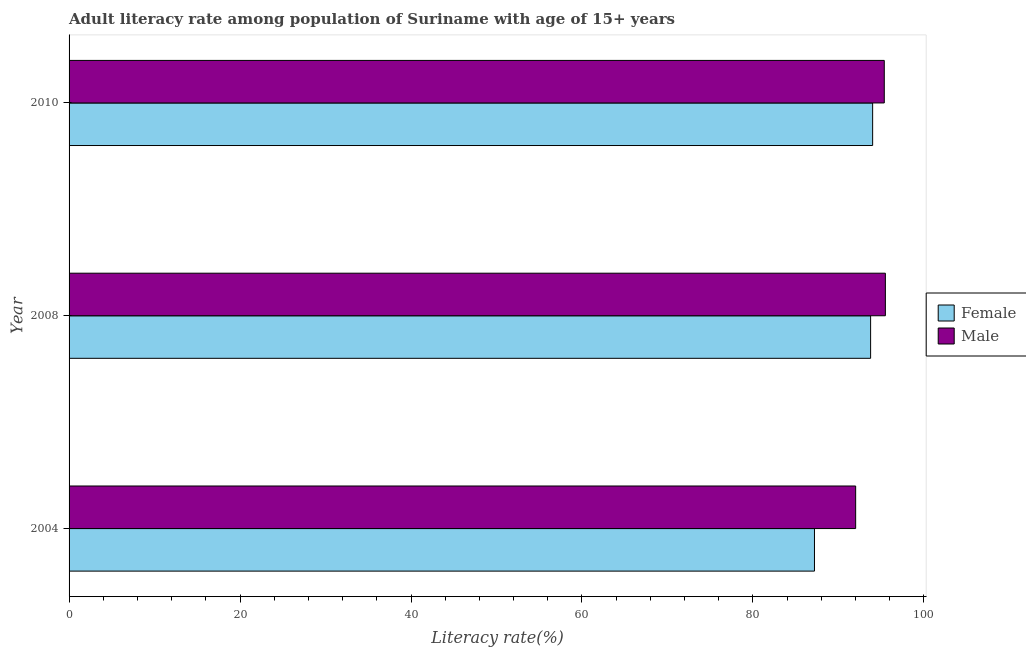Are the number of bars on each tick of the Y-axis equal?
Your answer should be very brief. Yes. How many bars are there on the 1st tick from the top?
Offer a terse response. 2. How many bars are there on the 1st tick from the bottom?
Provide a succinct answer. 2. In how many cases, is the number of bars for a given year not equal to the number of legend labels?
Keep it short and to the point. 0. What is the male adult literacy rate in 2008?
Offer a terse response. 95.49. Across all years, what is the maximum male adult literacy rate?
Give a very brief answer. 95.49. Across all years, what is the minimum male adult literacy rate?
Offer a very short reply. 92.02. In which year was the female adult literacy rate maximum?
Provide a succinct answer. 2010. In which year was the female adult literacy rate minimum?
Keep it short and to the point. 2004. What is the total male adult literacy rate in the graph?
Your answer should be compact. 282.87. What is the difference between the female adult literacy rate in 2004 and that in 2010?
Offer a very short reply. -6.81. What is the difference between the male adult literacy rate in 2010 and the female adult literacy rate in 2008?
Provide a succinct answer. 1.6. What is the average male adult literacy rate per year?
Your answer should be very brief. 94.29. In the year 2010, what is the difference between the male adult literacy rate and female adult literacy rate?
Your answer should be very brief. 1.36. What is the ratio of the female adult literacy rate in 2008 to that in 2010?
Keep it short and to the point. 1. What is the difference between the highest and the second highest male adult literacy rate?
Keep it short and to the point. 0.13. What is the difference between the highest and the lowest male adult literacy rate?
Your answer should be compact. 3.48. In how many years, is the female adult literacy rate greater than the average female adult literacy rate taken over all years?
Offer a terse response. 2. Is the sum of the male adult literacy rate in 2004 and 2010 greater than the maximum female adult literacy rate across all years?
Offer a very short reply. Yes. What does the 2nd bar from the bottom in 2010 represents?
Your answer should be compact. Male. How many years are there in the graph?
Give a very brief answer. 3. Does the graph contain any zero values?
Keep it short and to the point. No. Does the graph contain grids?
Ensure brevity in your answer.  No. How are the legend labels stacked?
Your answer should be very brief. Vertical. What is the title of the graph?
Your response must be concise. Adult literacy rate among population of Suriname with age of 15+ years. Does "Total Population" appear as one of the legend labels in the graph?
Keep it short and to the point. No. What is the label or title of the X-axis?
Offer a very short reply. Literacy rate(%). What is the label or title of the Y-axis?
Your answer should be very brief. Year. What is the Literacy rate(%) in Female in 2004?
Offer a very short reply. 87.2. What is the Literacy rate(%) of Male in 2004?
Provide a succinct answer. 92.02. What is the Literacy rate(%) of Female in 2008?
Offer a very short reply. 93.77. What is the Literacy rate(%) in Male in 2008?
Provide a short and direct response. 95.49. What is the Literacy rate(%) in Female in 2010?
Offer a terse response. 94. What is the Literacy rate(%) in Male in 2010?
Ensure brevity in your answer.  95.36. Across all years, what is the maximum Literacy rate(%) in Female?
Provide a short and direct response. 94. Across all years, what is the maximum Literacy rate(%) in Male?
Provide a succinct answer. 95.49. Across all years, what is the minimum Literacy rate(%) of Female?
Offer a terse response. 87.2. Across all years, what is the minimum Literacy rate(%) of Male?
Your response must be concise. 92.02. What is the total Literacy rate(%) in Female in the graph?
Keep it short and to the point. 274.97. What is the total Literacy rate(%) of Male in the graph?
Ensure brevity in your answer.  282.87. What is the difference between the Literacy rate(%) in Female in 2004 and that in 2008?
Offer a terse response. -6.57. What is the difference between the Literacy rate(%) of Male in 2004 and that in 2008?
Make the answer very short. -3.48. What is the difference between the Literacy rate(%) of Female in 2004 and that in 2010?
Your response must be concise. -6.81. What is the difference between the Literacy rate(%) in Male in 2004 and that in 2010?
Provide a short and direct response. -3.35. What is the difference between the Literacy rate(%) in Female in 2008 and that in 2010?
Ensure brevity in your answer.  -0.24. What is the difference between the Literacy rate(%) in Male in 2008 and that in 2010?
Give a very brief answer. 0.13. What is the difference between the Literacy rate(%) in Female in 2004 and the Literacy rate(%) in Male in 2008?
Your answer should be very brief. -8.3. What is the difference between the Literacy rate(%) in Female in 2004 and the Literacy rate(%) in Male in 2010?
Offer a terse response. -8.17. What is the difference between the Literacy rate(%) of Female in 2008 and the Literacy rate(%) of Male in 2010?
Provide a short and direct response. -1.6. What is the average Literacy rate(%) in Female per year?
Ensure brevity in your answer.  91.66. What is the average Literacy rate(%) in Male per year?
Offer a very short reply. 94.29. In the year 2004, what is the difference between the Literacy rate(%) in Female and Literacy rate(%) in Male?
Provide a succinct answer. -4.82. In the year 2008, what is the difference between the Literacy rate(%) of Female and Literacy rate(%) of Male?
Provide a succinct answer. -1.73. In the year 2010, what is the difference between the Literacy rate(%) of Female and Literacy rate(%) of Male?
Your answer should be very brief. -1.36. What is the ratio of the Literacy rate(%) in Male in 2004 to that in 2008?
Give a very brief answer. 0.96. What is the ratio of the Literacy rate(%) of Female in 2004 to that in 2010?
Your response must be concise. 0.93. What is the ratio of the Literacy rate(%) of Male in 2004 to that in 2010?
Give a very brief answer. 0.96. What is the ratio of the Literacy rate(%) of Female in 2008 to that in 2010?
Your answer should be compact. 1. What is the difference between the highest and the second highest Literacy rate(%) in Female?
Ensure brevity in your answer.  0.24. What is the difference between the highest and the second highest Literacy rate(%) of Male?
Ensure brevity in your answer.  0.13. What is the difference between the highest and the lowest Literacy rate(%) of Female?
Provide a short and direct response. 6.81. What is the difference between the highest and the lowest Literacy rate(%) of Male?
Offer a very short reply. 3.48. 